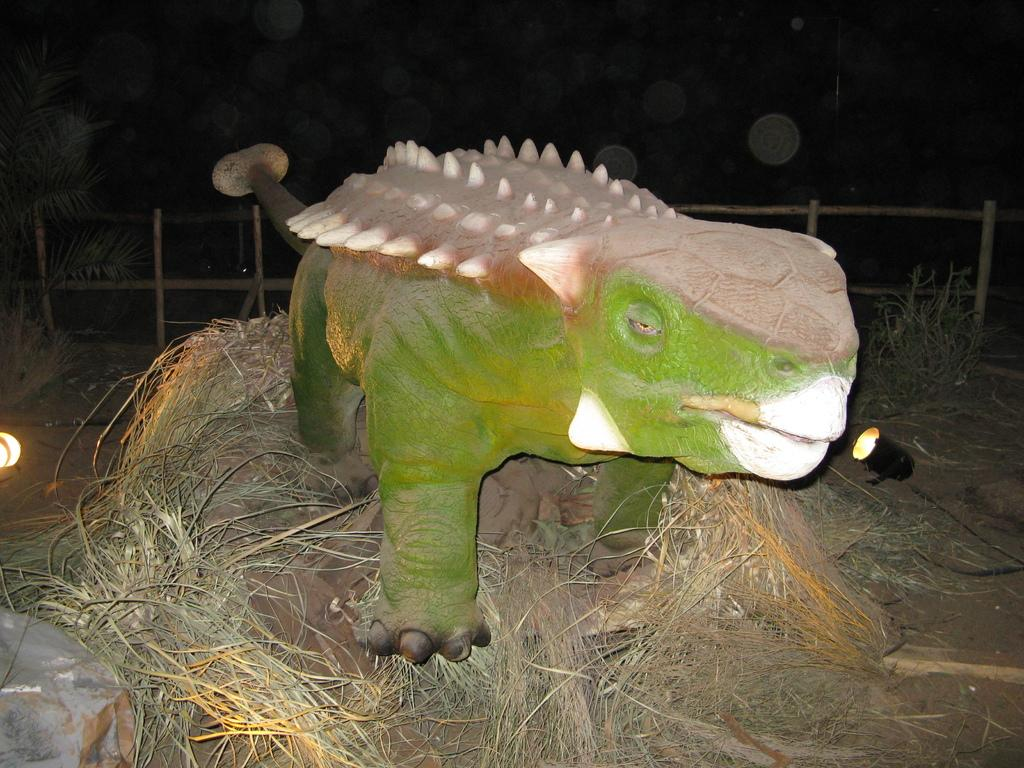What type of animal is in the image? The type of animal cannot be determined from the provided facts. What is the animal standing on? The animal is standing on grass. What can be seen in the background of the image? There is a fencing in the background of the image. What is the history of the recess depicted in the image? There is no recess present in the image, so it is not possible to discuss its history. 